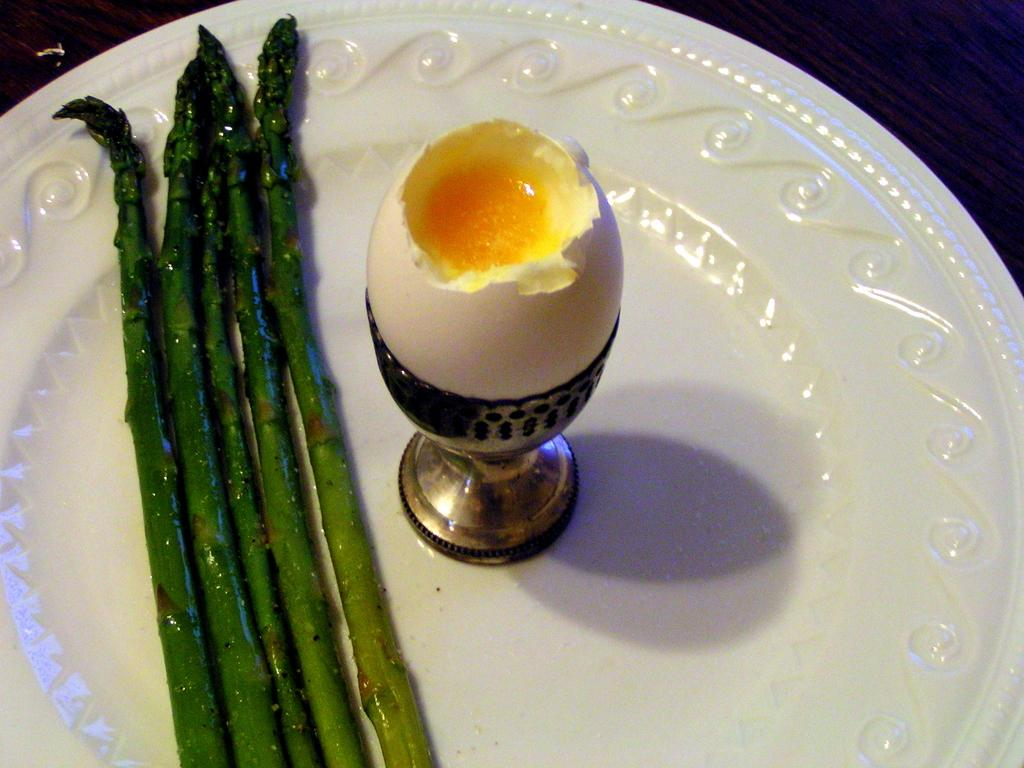What is on the plate in the image? There is a boiled egg on the plate, and there are also fried edible items. How is the boiled egg positioned on the plate? The boiled egg is on a stand on the plate. What type of food can be seen on the plate besides the boiled egg? There are fried edible items on the plate. What type of geese can be seen ringing bells in the image? There are no geese or bells present in the image. How does the plough contribute to the preparation of the food in the image? There is no plough present in the image, so it does not contribute to the preparation of the food. 